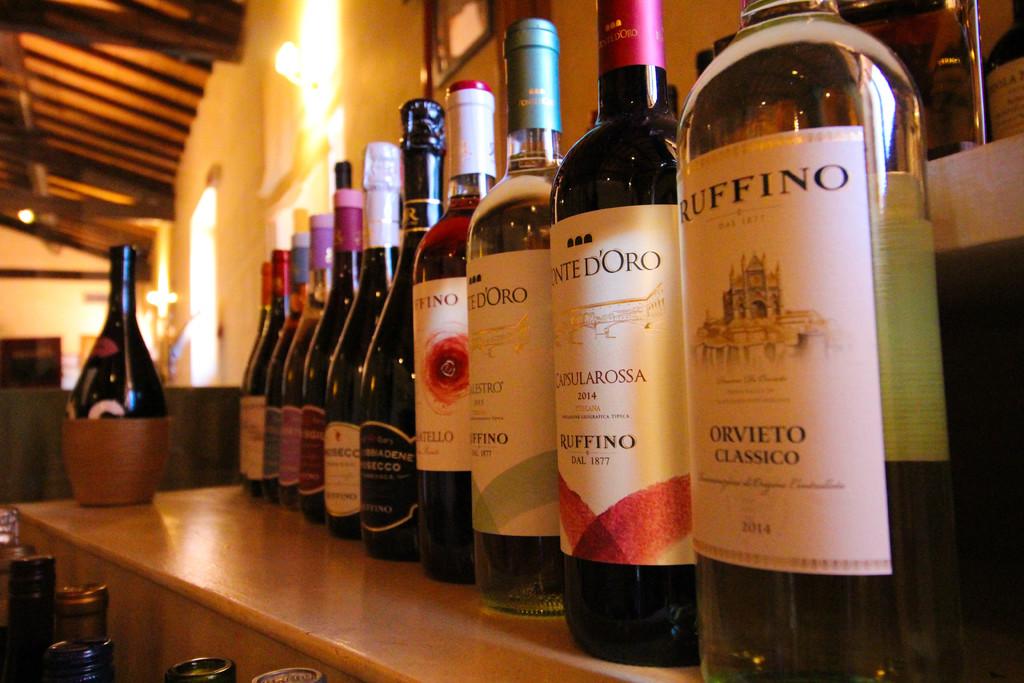What wine is that on the right?
Offer a terse response. Ruffino. What wine is second to the right?
Offer a terse response. Ruffino. 